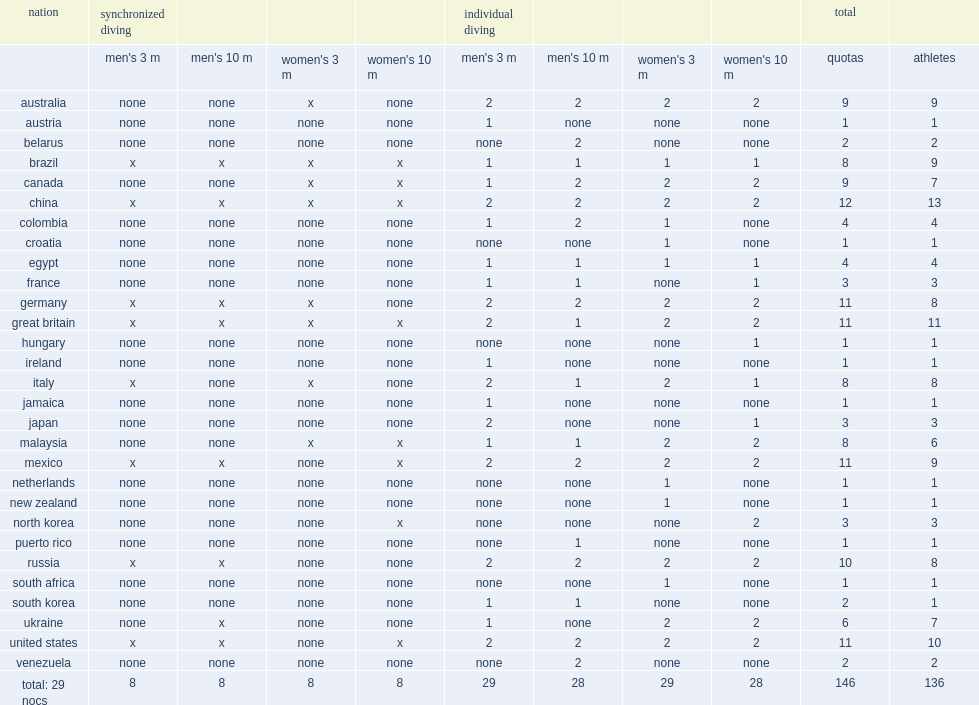How many athletes does the diving at the 2016 summer olympics have a total of athletes? 136.0. 